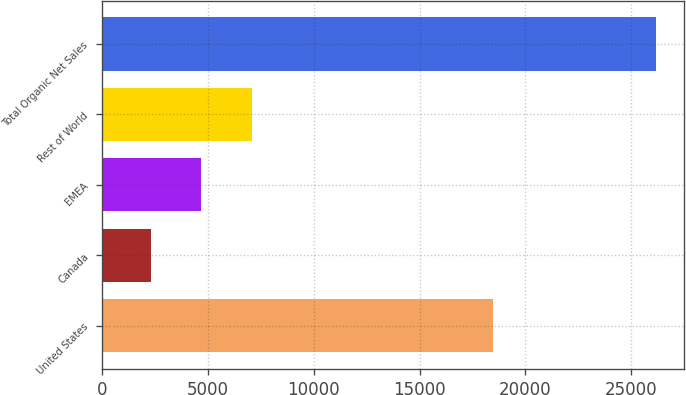<chart> <loc_0><loc_0><loc_500><loc_500><bar_chart><fcel>United States<fcel>Canada<fcel>EMEA<fcel>Rest of World<fcel>Total Organic Net Sales<nl><fcel>18469<fcel>2302<fcel>4690.6<fcel>7079.2<fcel>26188<nl></chart> 